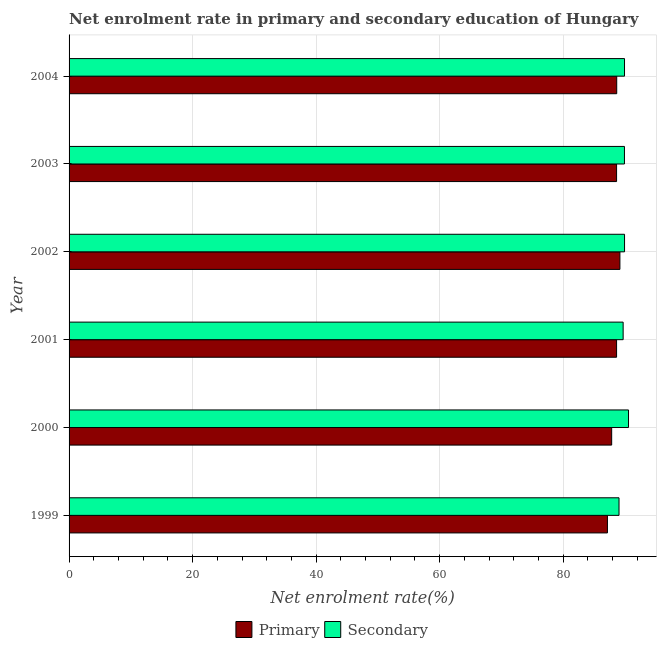Are the number of bars per tick equal to the number of legend labels?
Make the answer very short. Yes. Are the number of bars on each tick of the Y-axis equal?
Make the answer very short. Yes. What is the label of the 2nd group of bars from the top?
Your response must be concise. 2003. What is the enrollment rate in primary education in 2002?
Provide a succinct answer. 89.18. Across all years, what is the maximum enrollment rate in primary education?
Offer a very short reply. 89.18. Across all years, what is the minimum enrollment rate in primary education?
Provide a succinct answer. 87.16. In which year was the enrollment rate in primary education maximum?
Your answer should be very brief. 2002. What is the total enrollment rate in secondary education in the graph?
Your answer should be very brief. 539.08. What is the difference between the enrollment rate in primary education in 2003 and that in 2004?
Provide a short and direct response. -0.02. What is the difference between the enrollment rate in secondary education in 1999 and the enrollment rate in primary education in 2002?
Give a very brief answer. -0.14. What is the average enrollment rate in secondary education per year?
Ensure brevity in your answer.  89.85. In the year 2004, what is the difference between the enrollment rate in primary education and enrollment rate in secondary education?
Provide a succinct answer. -1.26. What is the ratio of the enrollment rate in secondary education in 2002 to that in 2004?
Your answer should be very brief. 1. Is the difference between the enrollment rate in primary education in 2001 and 2003 greater than the difference between the enrollment rate in secondary education in 2001 and 2003?
Your response must be concise. Yes. What is the difference between the highest and the second highest enrollment rate in primary education?
Offer a terse response. 0.51. What is the difference between the highest and the lowest enrollment rate in secondary education?
Offer a very short reply. 1.54. Is the sum of the enrollment rate in primary education in 2002 and 2004 greater than the maximum enrollment rate in secondary education across all years?
Offer a very short reply. Yes. What does the 2nd bar from the top in 2000 represents?
Ensure brevity in your answer.  Primary. What does the 2nd bar from the bottom in 2002 represents?
Make the answer very short. Secondary. How many bars are there?
Offer a terse response. 12. How many years are there in the graph?
Your answer should be compact. 6. Are the values on the major ticks of X-axis written in scientific E-notation?
Keep it short and to the point. No. How are the legend labels stacked?
Keep it short and to the point. Horizontal. What is the title of the graph?
Ensure brevity in your answer.  Net enrolment rate in primary and secondary education of Hungary. Does "Borrowers" appear as one of the legend labels in the graph?
Your answer should be very brief. No. What is the label or title of the X-axis?
Your answer should be compact. Net enrolment rate(%). What is the label or title of the Y-axis?
Provide a short and direct response. Year. What is the Net enrolment rate(%) of Primary in 1999?
Provide a succinct answer. 87.16. What is the Net enrolment rate(%) in Secondary in 1999?
Provide a succinct answer. 89.03. What is the Net enrolment rate(%) of Primary in 2000?
Your response must be concise. 87.85. What is the Net enrolment rate(%) in Secondary in 2000?
Your answer should be compact. 90.57. What is the Net enrolment rate(%) of Primary in 2001?
Your answer should be very brief. 88.64. What is the Net enrolment rate(%) in Secondary in 2001?
Your response must be concise. 89.7. What is the Net enrolment rate(%) in Primary in 2002?
Ensure brevity in your answer.  89.18. What is the Net enrolment rate(%) in Secondary in 2002?
Provide a short and direct response. 89.93. What is the Net enrolment rate(%) of Primary in 2003?
Provide a succinct answer. 88.64. What is the Net enrolment rate(%) of Secondary in 2003?
Provide a short and direct response. 89.91. What is the Net enrolment rate(%) of Primary in 2004?
Your response must be concise. 88.66. What is the Net enrolment rate(%) in Secondary in 2004?
Your response must be concise. 89.92. Across all years, what is the maximum Net enrolment rate(%) of Primary?
Give a very brief answer. 89.18. Across all years, what is the maximum Net enrolment rate(%) of Secondary?
Keep it short and to the point. 90.57. Across all years, what is the minimum Net enrolment rate(%) in Primary?
Give a very brief answer. 87.16. Across all years, what is the minimum Net enrolment rate(%) in Secondary?
Provide a succinct answer. 89.03. What is the total Net enrolment rate(%) of Primary in the graph?
Your answer should be compact. 530.12. What is the total Net enrolment rate(%) of Secondary in the graph?
Keep it short and to the point. 539.08. What is the difference between the Net enrolment rate(%) of Primary in 1999 and that in 2000?
Ensure brevity in your answer.  -0.69. What is the difference between the Net enrolment rate(%) in Secondary in 1999 and that in 2000?
Keep it short and to the point. -1.54. What is the difference between the Net enrolment rate(%) in Primary in 1999 and that in 2001?
Provide a short and direct response. -1.48. What is the difference between the Net enrolment rate(%) of Secondary in 1999 and that in 2001?
Your response must be concise. -0.67. What is the difference between the Net enrolment rate(%) in Primary in 1999 and that in 2002?
Your answer should be very brief. -2.02. What is the difference between the Net enrolment rate(%) in Secondary in 1999 and that in 2002?
Provide a short and direct response. -0.89. What is the difference between the Net enrolment rate(%) in Primary in 1999 and that in 2003?
Your response must be concise. -1.48. What is the difference between the Net enrolment rate(%) in Secondary in 1999 and that in 2003?
Offer a terse response. -0.88. What is the difference between the Net enrolment rate(%) of Primary in 1999 and that in 2004?
Give a very brief answer. -1.5. What is the difference between the Net enrolment rate(%) of Secondary in 1999 and that in 2004?
Offer a terse response. -0.89. What is the difference between the Net enrolment rate(%) in Primary in 2000 and that in 2001?
Your response must be concise. -0.79. What is the difference between the Net enrolment rate(%) of Secondary in 2000 and that in 2001?
Your response must be concise. 0.87. What is the difference between the Net enrolment rate(%) in Primary in 2000 and that in 2002?
Make the answer very short. -1.33. What is the difference between the Net enrolment rate(%) in Secondary in 2000 and that in 2002?
Provide a short and direct response. 0.64. What is the difference between the Net enrolment rate(%) in Primary in 2000 and that in 2003?
Your answer should be very brief. -0.79. What is the difference between the Net enrolment rate(%) of Secondary in 2000 and that in 2003?
Give a very brief answer. 0.66. What is the difference between the Net enrolment rate(%) in Primary in 2000 and that in 2004?
Provide a succinct answer. -0.82. What is the difference between the Net enrolment rate(%) of Secondary in 2000 and that in 2004?
Your response must be concise. 0.65. What is the difference between the Net enrolment rate(%) of Primary in 2001 and that in 2002?
Keep it short and to the point. -0.54. What is the difference between the Net enrolment rate(%) of Secondary in 2001 and that in 2002?
Make the answer very short. -0.23. What is the difference between the Net enrolment rate(%) in Primary in 2001 and that in 2003?
Your answer should be very brief. -0. What is the difference between the Net enrolment rate(%) in Secondary in 2001 and that in 2003?
Offer a terse response. -0.21. What is the difference between the Net enrolment rate(%) in Primary in 2001 and that in 2004?
Provide a succinct answer. -0.02. What is the difference between the Net enrolment rate(%) of Secondary in 2001 and that in 2004?
Your answer should be compact. -0.22. What is the difference between the Net enrolment rate(%) in Primary in 2002 and that in 2003?
Provide a short and direct response. 0.54. What is the difference between the Net enrolment rate(%) in Secondary in 2002 and that in 2003?
Your answer should be compact. 0.01. What is the difference between the Net enrolment rate(%) in Primary in 2002 and that in 2004?
Offer a very short reply. 0.51. What is the difference between the Net enrolment rate(%) in Secondary in 2002 and that in 2004?
Make the answer very short. 0.01. What is the difference between the Net enrolment rate(%) of Primary in 2003 and that in 2004?
Give a very brief answer. -0.02. What is the difference between the Net enrolment rate(%) in Secondary in 2003 and that in 2004?
Provide a succinct answer. -0.01. What is the difference between the Net enrolment rate(%) in Primary in 1999 and the Net enrolment rate(%) in Secondary in 2000?
Your answer should be very brief. -3.41. What is the difference between the Net enrolment rate(%) in Primary in 1999 and the Net enrolment rate(%) in Secondary in 2001?
Make the answer very short. -2.54. What is the difference between the Net enrolment rate(%) in Primary in 1999 and the Net enrolment rate(%) in Secondary in 2002?
Offer a very short reply. -2.77. What is the difference between the Net enrolment rate(%) in Primary in 1999 and the Net enrolment rate(%) in Secondary in 2003?
Your answer should be very brief. -2.75. What is the difference between the Net enrolment rate(%) of Primary in 1999 and the Net enrolment rate(%) of Secondary in 2004?
Ensure brevity in your answer.  -2.76. What is the difference between the Net enrolment rate(%) in Primary in 2000 and the Net enrolment rate(%) in Secondary in 2001?
Your answer should be compact. -1.86. What is the difference between the Net enrolment rate(%) of Primary in 2000 and the Net enrolment rate(%) of Secondary in 2002?
Keep it short and to the point. -2.08. What is the difference between the Net enrolment rate(%) in Primary in 2000 and the Net enrolment rate(%) in Secondary in 2003?
Keep it short and to the point. -2.07. What is the difference between the Net enrolment rate(%) of Primary in 2000 and the Net enrolment rate(%) of Secondary in 2004?
Your response must be concise. -2.08. What is the difference between the Net enrolment rate(%) of Primary in 2001 and the Net enrolment rate(%) of Secondary in 2002?
Keep it short and to the point. -1.29. What is the difference between the Net enrolment rate(%) of Primary in 2001 and the Net enrolment rate(%) of Secondary in 2003?
Keep it short and to the point. -1.28. What is the difference between the Net enrolment rate(%) in Primary in 2001 and the Net enrolment rate(%) in Secondary in 2004?
Offer a very short reply. -1.28. What is the difference between the Net enrolment rate(%) of Primary in 2002 and the Net enrolment rate(%) of Secondary in 2003?
Your answer should be very brief. -0.74. What is the difference between the Net enrolment rate(%) of Primary in 2002 and the Net enrolment rate(%) of Secondary in 2004?
Ensure brevity in your answer.  -0.75. What is the difference between the Net enrolment rate(%) in Primary in 2003 and the Net enrolment rate(%) in Secondary in 2004?
Offer a terse response. -1.28. What is the average Net enrolment rate(%) in Primary per year?
Your response must be concise. 88.35. What is the average Net enrolment rate(%) in Secondary per year?
Provide a succinct answer. 89.85. In the year 1999, what is the difference between the Net enrolment rate(%) in Primary and Net enrolment rate(%) in Secondary?
Provide a short and direct response. -1.87. In the year 2000, what is the difference between the Net enrolment rate(%) in Primary and Net enrolment rate(%) in Secondary?
Give a very brief answer. -2.73. In the year 2001, what is the difference between the Net enrolment rate(%) in Primary and Net enrolment rate(%) in Secondary?
Offer a very short reply. -1.06. In the year 2002, what is the difference between the Net enrolment rate(%) of Primary and Net enrolment rate(%) of Secondary?
Your answer should be very brief. -0.75. In the year 2003, what is the difference between the Net enrolment rate(%) in Primary and Net enrolment rate(%) in Secondary?
Your response must be concise. -1.27. In the year 2004, what is the difference between the Net enrolment rate(%) in Primary and Net enrolment rate(%) in Secondary?
Provide a short and direct response. -1.26. What is the ratio of the Net enrolment rate(%) of Primary in 1999 to that in 2000?
Make the answer very short. 0.99. What is the ratio of the Net enrolment rate(%) in Secondary in 1999 to that in 2000?
Your answer should be very brief. 0.98. What is the ratio of the Net enrolment rate(%) of Primary in 1999 to that in 2001?
Your answer should be compact. 0.98. What is the ratio of the Net enrolment rate(%) of Secondary in 1999 to that in 2001?
Your answer should be compact. 0.99. What is the ratio of the Net enrolment rate(%) of Primary in 1999 to that in 2002?
Provide a short and direct response. 0.98. What is the ratio of the Net enrolment rate(%) of Secondary in 1999 to that in 2002?
Your answer should be compact. 0.99. What is the ratio of the Net enrolment rate(%) of Primary in 1999 to that in 2003?
Keep it short and to the point. 0.98. What is the ratio of the Net enrolment rate(%) in Secondary in 1999 to that in 2003?
Offer a terse response. 0.99. What is the ratio of the Net enrolment rate(%) of Primary in 1999 to that in 2004?
Provide a short and direct response. 0.98. What is the ratio of the Net enrolment rate(%) in Primary in 2000 to that in 2001?
Your answer should be compact. 0.99. What is the ratio of the Net enrolment rate(%) in Secondary in 2000 to that in 2001?
Offer a very short reply. 1.01. What is the ratio of the Net enrolment rate(%) in Primary in 2000 to that in 2002?
Make the answer very short. 0.99. What is the ratio of the Net enrolment rate(%) in Secondary in 2000 to that in 2002?
Your response must be concise. 1.01. What is the ratio of the Net enrolment rate(%) in Primary in 2000 to that in 2003?
Provide a short and direct response. 0.99. What is the ratio of the Net enrolment rate(%) of Secondary in 2000 to that in 2003?
Provide a short and direct response. 1.01. What is the ratio of the Net enrolment rate(%) of Secondary in 2000 to that in 2004?
Provide a succinct answer. 1.01. What is the ratio of the Net enrolment rate(%) of Secondary in 2001 to that in 2002?
Offer a terse response. 1. What is the ratio of the Net enrolment rate(%) of Primary in 2001 to that in 2003?
Make the answer very short. 1. What is the ratio of the Net enrolment rate(%) of Secondary in 2002 to that in 2003?
Give a very brief answer. 1. What is the ratio of the Net enrolment rate(%) of Secondary in 2002 to that in 2004?
Keep it short and to the point. 1. What is the ratio of the Net enrolment rate(%) of Primary in 2003 to that in 2004?
Your response must be concise. 1. What is the difference between the highest and the second highest Net enrolment rate(%) in Primary?
Provide a succinct answer. 0.51. What is the difference between the highest and the second highest Net enrolment rate(%) in Secondary?
Your answer should be very brief. 0.64. What is the difference between the highest and the lowest Net enrolment rate(%) of Primary?
Offer a very short reply. 2.02. What is the difference between the highest and the lowest Net enrolment rate(%) of Secondary?
Provide a short and direct response. 1.54. 